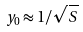<formula> <loc_0><loc_0><loc_500><loc_500>y _ { 0 } \approx 1 / \sqrt { S }</formula> 